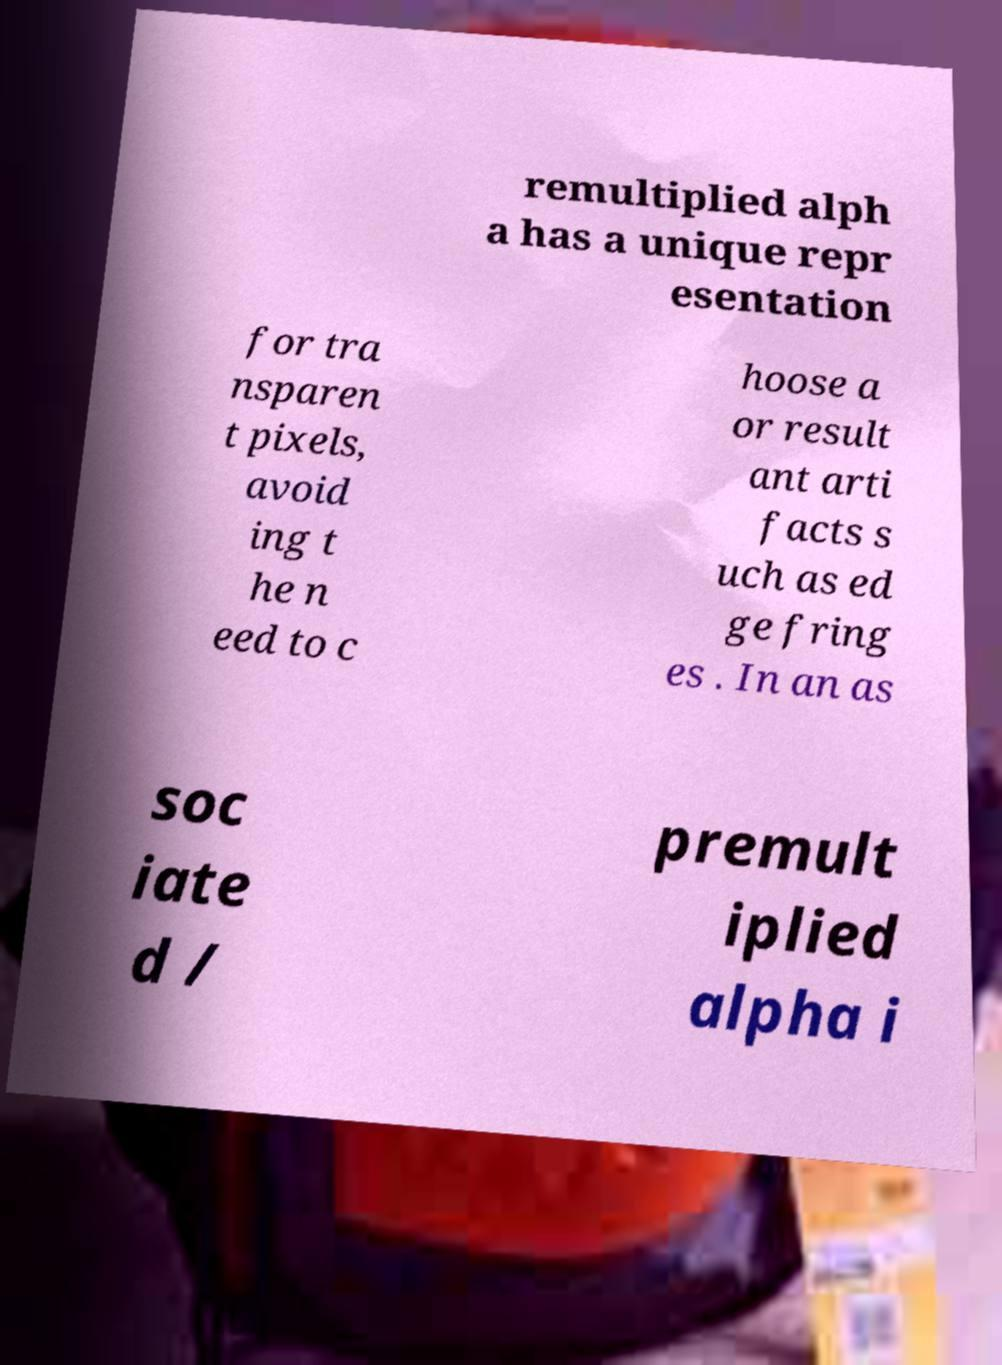Could you assist in decoding the text presented in this image and type it out clearly? remultiplied alph a has a unique repr esentation for tra nsparen t pixels, avoid ing t he n eed to c hoose a or result ant arti facts s uch as ed ge fring es . In an as soc iate d / premult iplied alpha i 